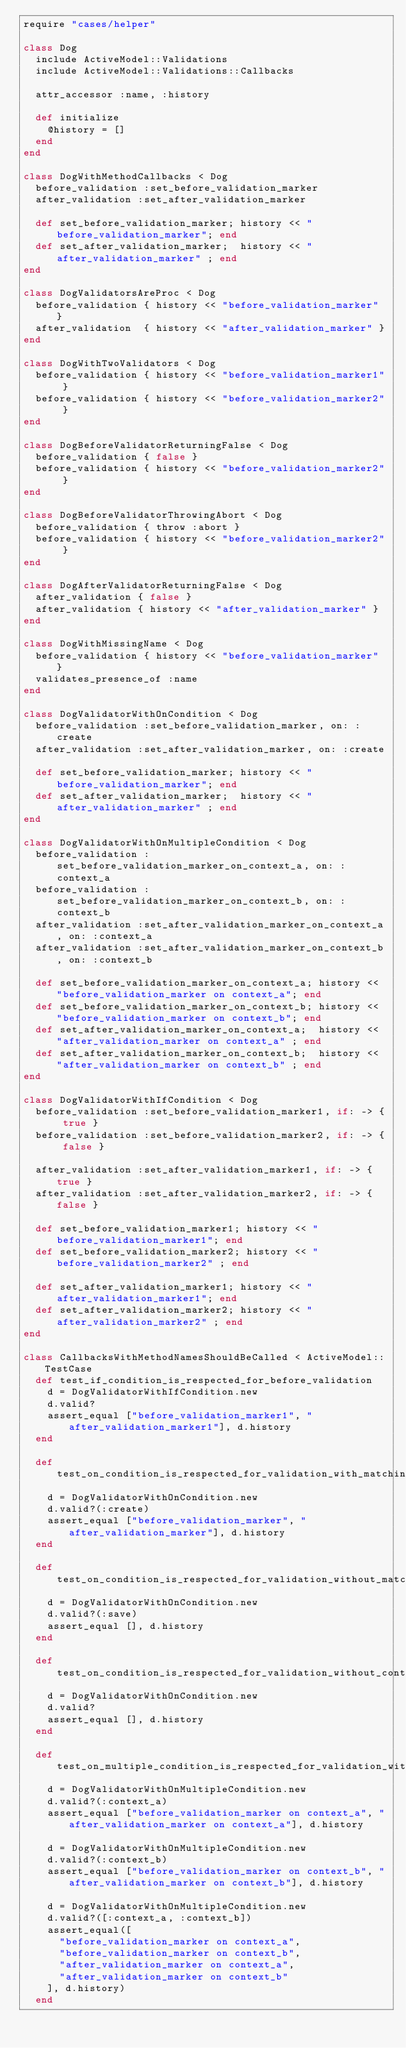<code> <loc_0><loc_0><loc_500><loc_500><_Ruby_>require "cases/helper"

class Dog
  include ActiveModel::Validations
  include ActiveModel::Validations::Callbacks

  attr_accessor :name, :history

  def initialize
    @history = []
  end
end

class DogWithMethodCallbacks < Dog
  before_validation :set_before_validation_marker
  after_validation :set_after_validation_marker

  def set_before_validation_marker; history << "before_validation_marker"; end
  def set_after_validation_marker;  history << "after_validation_marker" ; end
end

class DogValidatorsAreProc < Dog
  before_validation { history << "before_validation_marker" }
  after_validation  { history << "after_validation_marker" }
end

class DogWithTwoValidators < Dog
  before_validation { history << "before_validation_marker1" }
  before_validation { history << "before_validation_marker2" }
end

class DogBeforeValidatorReturningFalse < Dog
  before_validation { false }
  before_validation { history << "before_validation_marker2" }
end

class DogBeforeValidatorThrowingAbort < Dog
  before_validation { throw :abort }
  before_validation { history << "before_validation_marker2" }
end

class DogAfterValidatorReturningFalse < Dog
  after_validation { false }
  after_validation { history << "after_validation_marker" }
end

class DogWithMissingName < Dog
  before_validation { history << "before_validation_marker" }
  validates_presence_of :name
end

class DogValidatorWithOnCondition < Dog
  before_validation :set_before_validation_marker, on: :create
  after_validation :set_after_validation_marker, on: :create

  def set_before_validation_marker; history << "before_validation_marker"; end
  def set_after_validation_marker;  history << "after_validation_marker" ; end
end

class DogValidatorWithOnMultipleCondition < Dog
  before_validation :set_before_validation_marker_on_context_a, on: :context_a
  before_validation :set_before_validation_marker_on_context_b, on: :context_b
  after_validation :set_after_validation_marker_on_context_a, on: :context_a
  after_validation :set_after_validation_marker_on_context_b, on: :context_b

  def set_before_validation_marker_on_context_a; history << "before_validation_marker on context_a"; end
  def set_before_validation_marker_on_context_b; history << "before_validation_marker on context_b"; end
  def set_after_validation_marker_on_context_a;  history << "after_validation_marker on context_a" ; end
  def set_after_validation_marker_on_context_b;  history << "after_validation_marker on context_b" ; end
end

class DogValidatorWithIfCondition < Dog
  before_validation :set_before_validation_marker1, if: -> { true }
  before_validation :set_before_validation_marker2, if: -> { false }

  after_validation :set_after_validation_marker1, if: -> { true }
  after_validation :set_after_validation_marker2, if: -> { false }

  def set_before_validation_marker1; history << "before_validation_marker1"; end
  def set_before_validation_marker2; history << "before_validation_marker2" ; end

  def set_after_validation_marker1; history << "after_validation_marker1"; end
  def set_after_validation_marker2; history << "after_validation_marker2" ; end
end

class CallbacksWithMethodNamesShouldBeCalled < ActiveModel::TestCase
  def test_if_condition_is_respected_for_before_validation
    d = DogValidatorWithIfCondition.new
    d.valid?
    assert_equal ["before_validation_marker1", "after_validation_marker1"], d.history
  end

  def test_on_condition_is_respected_for_validation_with_matching_context
    d = DogValidatorWithOnCondition.new
    d.valid?(:create)
    assert_equal ["before_validation_marker", "after_validation_marker"], d.history
  end

  def test_on_condition_is_respected_for_validation_without_matching_context
    d = DogValidatorWithOnCondition.new
    d.valid?(:save)
    assert_equal [], d.history
  end

  def test_on_condition_is_respected_for_validation_without_context
    d = DogValidatorWithOnCondition.new
    d.valid?
    assert_equal [], d.history
  end

  def test_on_multiple_condition_is_respected_for_validation_with_matching_context
    d = DogValidatorWithOnMultipleCondition.new
    d.valid?(:context_a)
    assert_equal ["before_validation_marker on context_a", "after_validation_marker on context_a"], d.history

    d = DogValidatorWithOnMultipleCondition.new
    d.valid?(:context_b)
    assert_equal ["before_validation_marker on context_b", "after_validation_marker on context_b"], d.history

    d = DogValidatorWithOnMultipleCondition.new
    d.valid?([:context_a, :context_b])
    assert_equal([
      "before_validation_marker on context_a",
      "before_validation_marker on context_b",
      "after_validation_marker on context_a",
      "after_validation_marker on context_b"
    ], d.history)
  end
</code> 